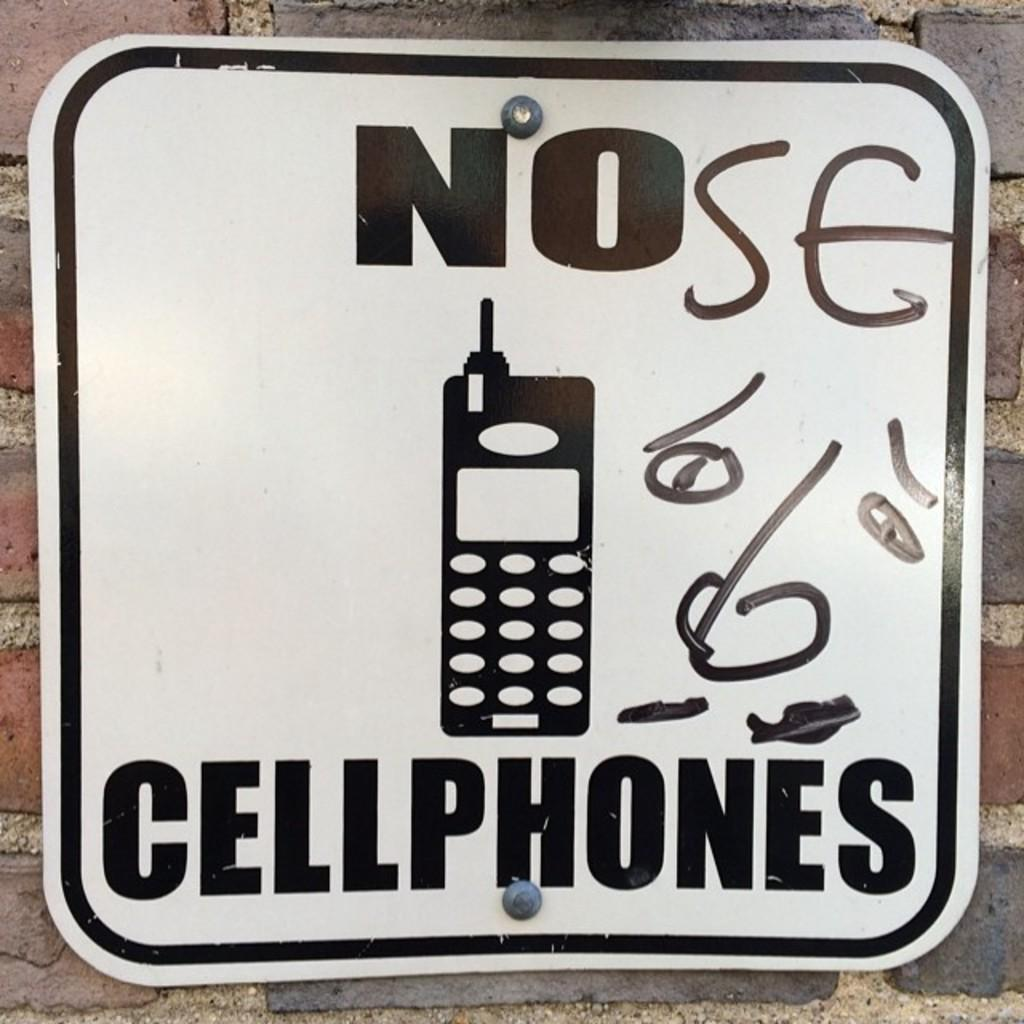<image>
Write a terse but informative summary of the picture. a sign displaying no cellphones use in black and white 